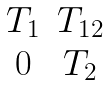<formula> <loc_0><loc_0><loc_500><loc_500>\begin{matrix} T _ { 1 } & T _ { 1 2 } \\ 0 & T _ { 2 } \end{matrix}</formula> 